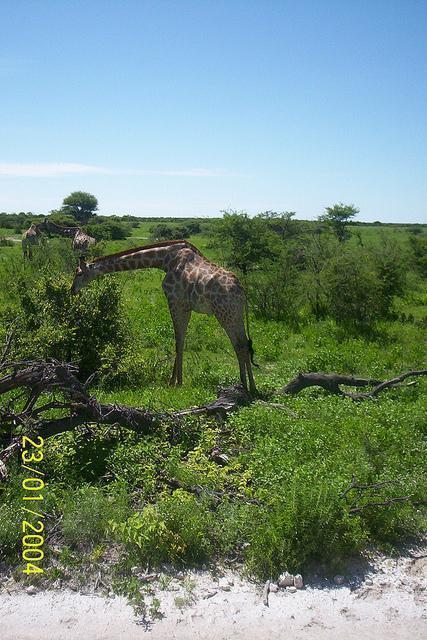How many giraffes can be seen?
Give a very brief answer. 1. How many birds are there?
Give a very brief answer. 0. 